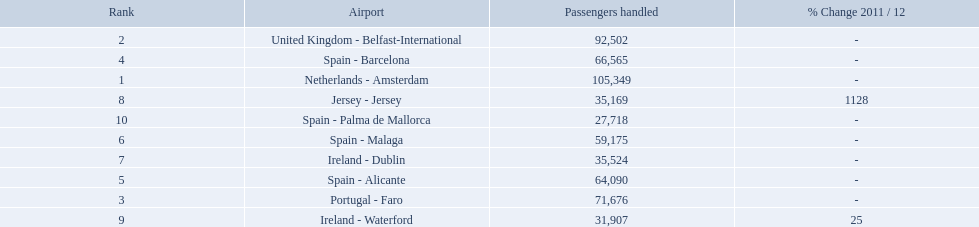What are the airports? Netherlands - Amsterdam, United Kingdom - Belfast-International, Portugal - Faro, Spain - Barcelona, Spain - Alicante, Spain - Malaga, Ireland - Dublin, Jersey - Jersey, Ireland - Waterford, Spain - Palma de Mallorca. Of these which has the least amount of passengers? Spain - Palma de Mallorca. 